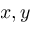<formula> <loc_0><loc_0><loc_500><loc_500>x , y</formula> 